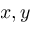<formula> <loc_0><loc_0><loc_500><loc_500>x , y</formula> 